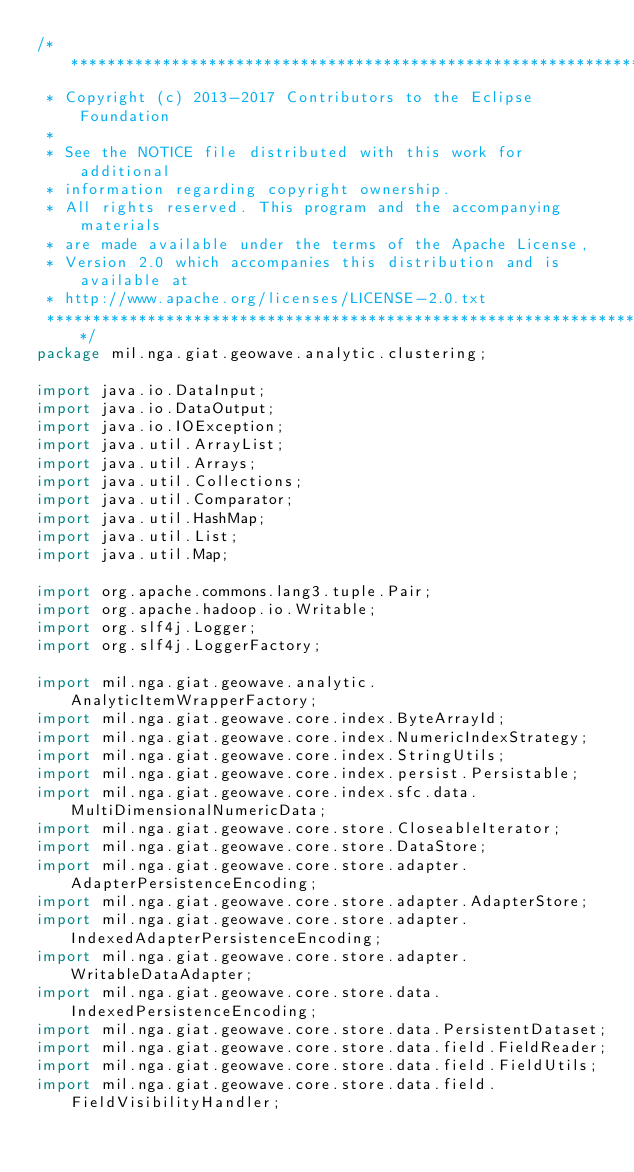Convert code to text. <code><loc_0><loc_0><loc_500><loc_500><_Java_>/*******************************************************************************
 * Copyright (c) 2013-2017 Contributors to the Eclipse Foundation
 * 
 * See the NOTICE file distributed with this work for additional
 * information regarding copyright ownership.
 * All rights reserved. This program and the accompanying materials
 * are made available under the terms of the Apache License,
 * Version 2.0 which accompanies this distribution and is available at
 * http://www.apache.org/licenses/LICENSE-2.0.txt
 ******************************************************************************/
package mil.nga.giat.geowave.analytic.clustering;

import java.io.DataInput;
import java.io.DataOutput;
import java.io.IOException;
import java.util.ArrayList;
import java.util.Arrays;
import java.util.Collections;
import java.util.Comparator;
import java.util.HashMap;
import java.util.List;
import java.util.Map;

import org.apache.commons.lang3.tuple.Pair;
import org.apache.hadoop.io.Writable;
import org.slf4j.Logger;
import org.slf4j.LoggerFactory;

import mil.nga.giat.geowave.analytic.AnalyticItemWrapperFactory;
import mil.nga.giat.geowave.core.index.ByteArrayId;
import mil.nga.giat.geowave.core.index.NumericIndexStrategy;
import mil.nga.giat.geowave.core.index.StringUtils;
import mil.nga.giat.geowave.core.index.persist.Persistable;
import mil.nga.giat.geowave.core.index.sfc.data.MultiDimensionalNumericData;
import mil.nga.giat.geowave.core.store.CloseableIterator;
import mil.nga.giat.geowave.core.store.DataStore;
import mil.nga.giat.geowave.core.store.adapter.AdapterPersistenceEncoding;
import mil.nga.giat.geowave.core.store.adapter.AdapterStore;
import mil.nga.giat.geowave.core.store.adapter.IndexedAdapterPersistenceEncoding;
import mil.nga.giat.geowave.core.store.adapter.WritableDataAdapter;
import mil.nga.giat.geowave.core.store.data.IndexedPersistenceEncoding;
import mil.nga.giat.geowave.core.store.data.PersistentDataset;
import mil.nga.giat.geowave.core.store.data.field.FieldReader;
import mil.nga.giat.geowave.core.store.data.field.FieldUtils;
import mil.nga.giat.geowave.core.store.data.field.FieldVisibilityHandler;</code> 